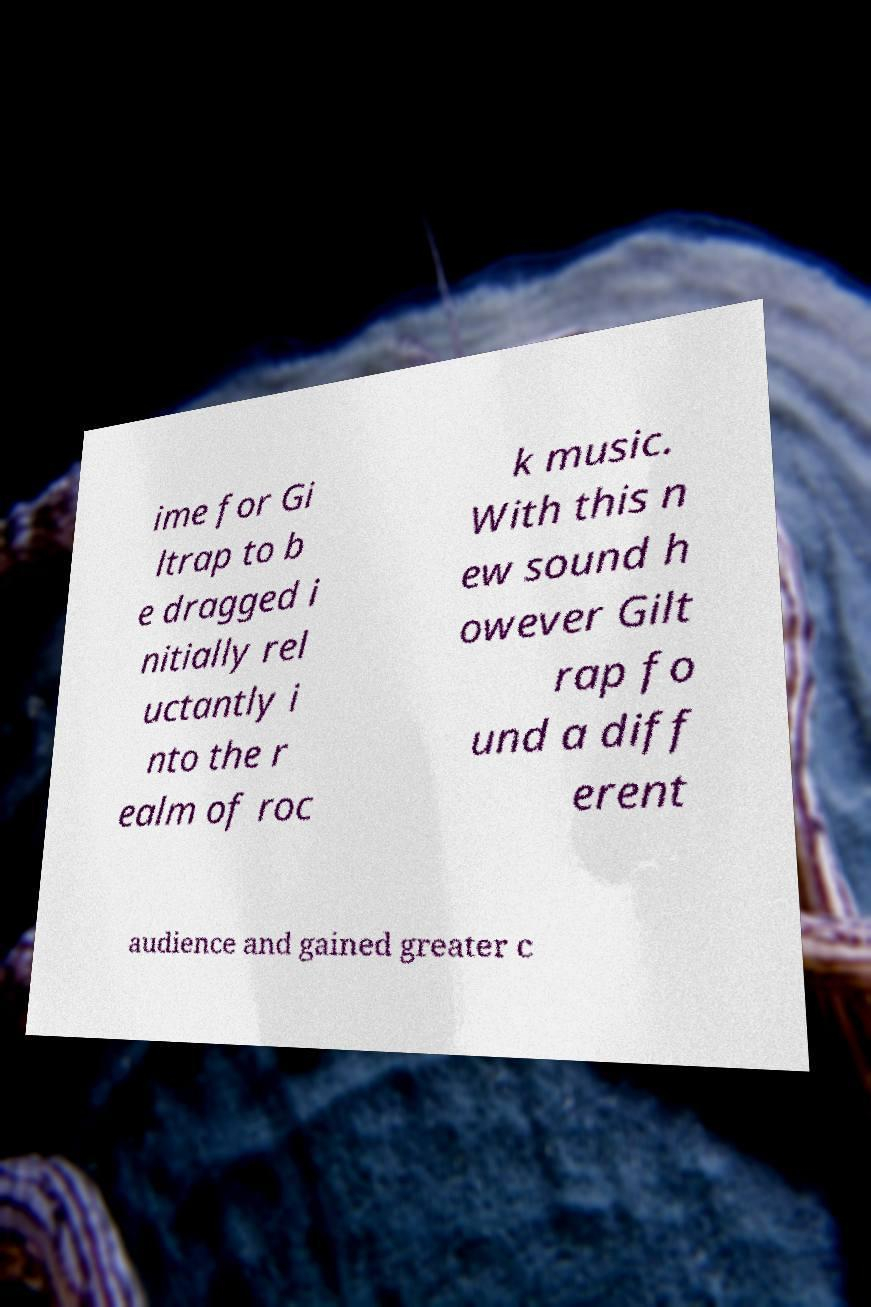Could you extract and type out the text from this image? ime for Gi ltrap to b e dragged i nitially rel uctantly i nto the r ealm of roc k music. With this n ew sound h owever Gilt rap fo und a diff erent audience and gained greater c 